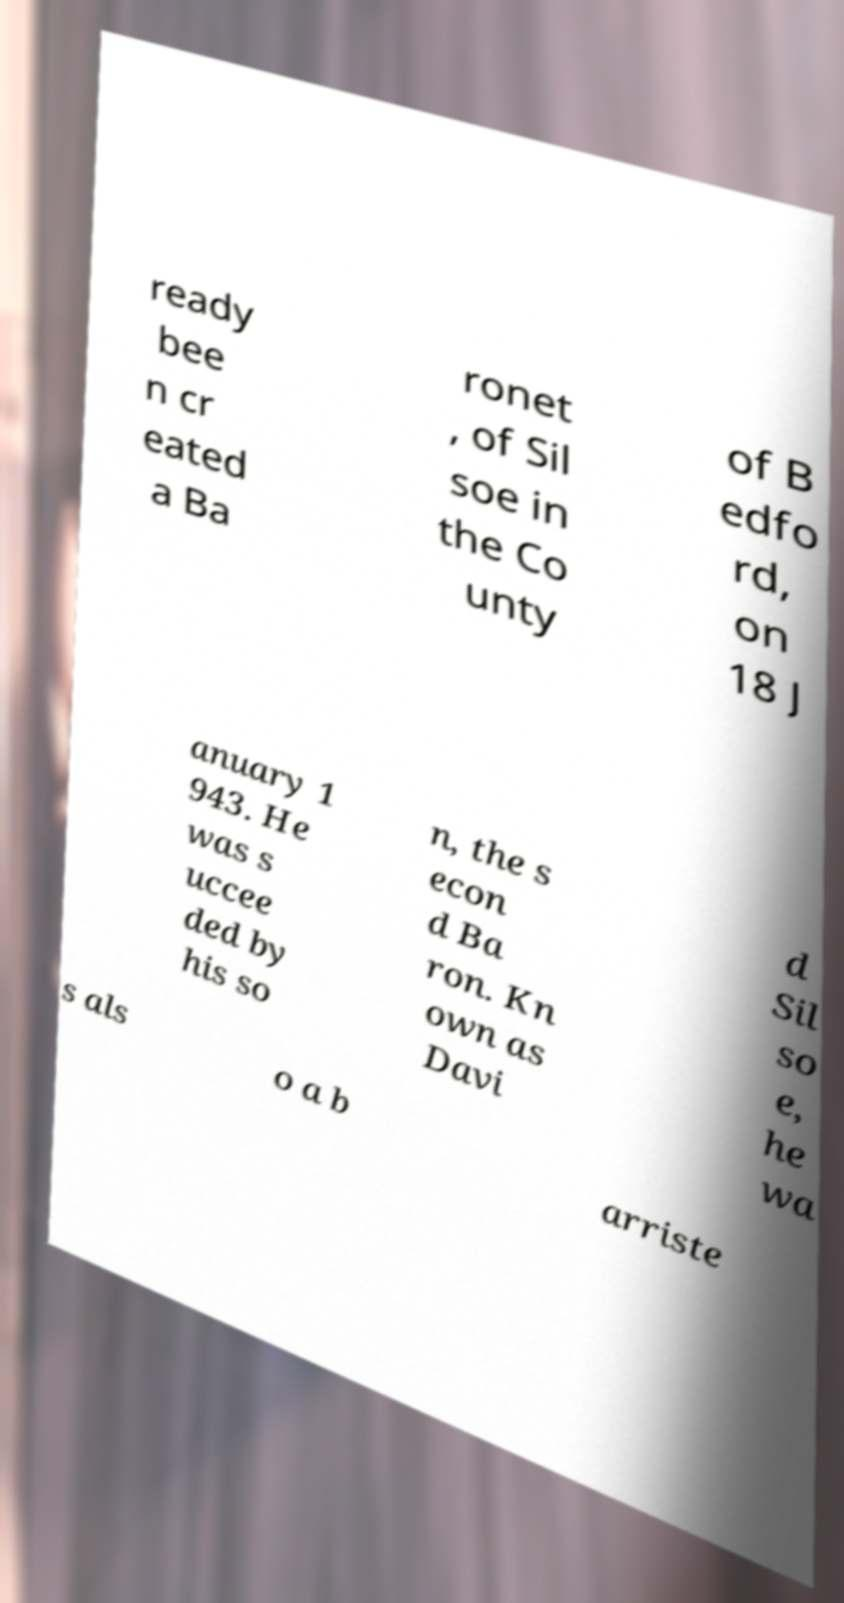There's text embedded in this image that I need extracted. Can you transcribe it verbatim? ready bee n cr eated a Ba ronet , of Sil soe in the Co unty of B edfo rd, on 18 J anuary 1 943. He was s uccee ded by his so n, the s econ d Ba ron. Kn own as Davi d Sil so e, he wa s als o a b arriste 